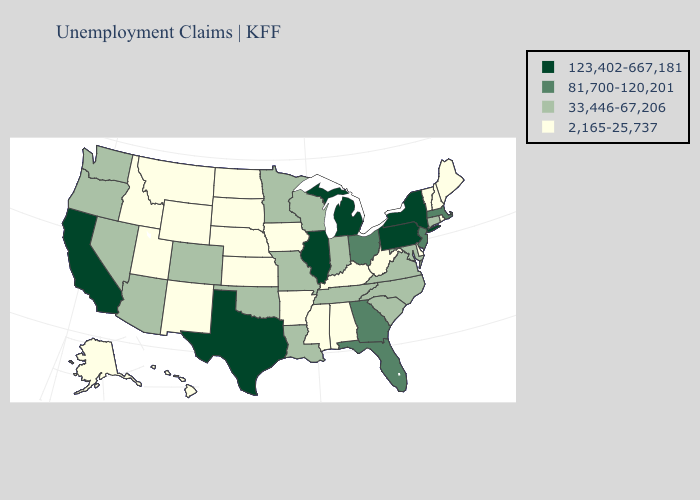Name the states that have a value in the range 33,446-67,206?
Keep it brief. Arizona, Colorado, Connecticut, Indiana, Louisiana, Maryland, Minnesota, Missouri, Nevada, North Carolina, Oklahoma, Oregon, South Carolina, Tennessee, Virginia, Washington, Wisconsin. Name the states that have a value in the range 123,402-667,181?
Answer briefly. California, Illinois, Michigan, New York, Pennsylvania, Texas. Does Arizona have the highest value in the USA?
Give a very brief answer. No. Among the states that border Georgia , does Florida have the highest value?
Short answer required. Yes. What is the highest value in the USA?
Answer briefly. 123,402-667,181. What is the lowest value in the USA?
Concise answer only. 2,165-25,737. Among the states that border New Jersey , which have the highest value?
Be succinct. New York, Pennsylvania. What is the value of Iowa?
Answer briefly. 2,165-25,737. How many symbols are there in the legend?
Quick response, please. 4. What is the lowest value in states that border Wisconsin?
Give a very brief answer. 2,165-25,737. Among the states that border Tennessee , does Missouri have the lowest value?
Give a very brief answer. No. What is the highest value in the South ?
Be succinct. 123,402-667,181. Among the states that border Tennessee , which have the lowest value?
Short answer required. Alabama, Arkansas, Kentucky, Mississippi. Name the states that have a value in the range 123,402-667,181?
Answer briefly. California, Illinois, Michigan, New York, Pennsylvania, Texas. Name the states that have a value in the range 123,402-667,181?
Short answer required. California, Illinois, Michigan, New York, Pennsylvania, Texas. 